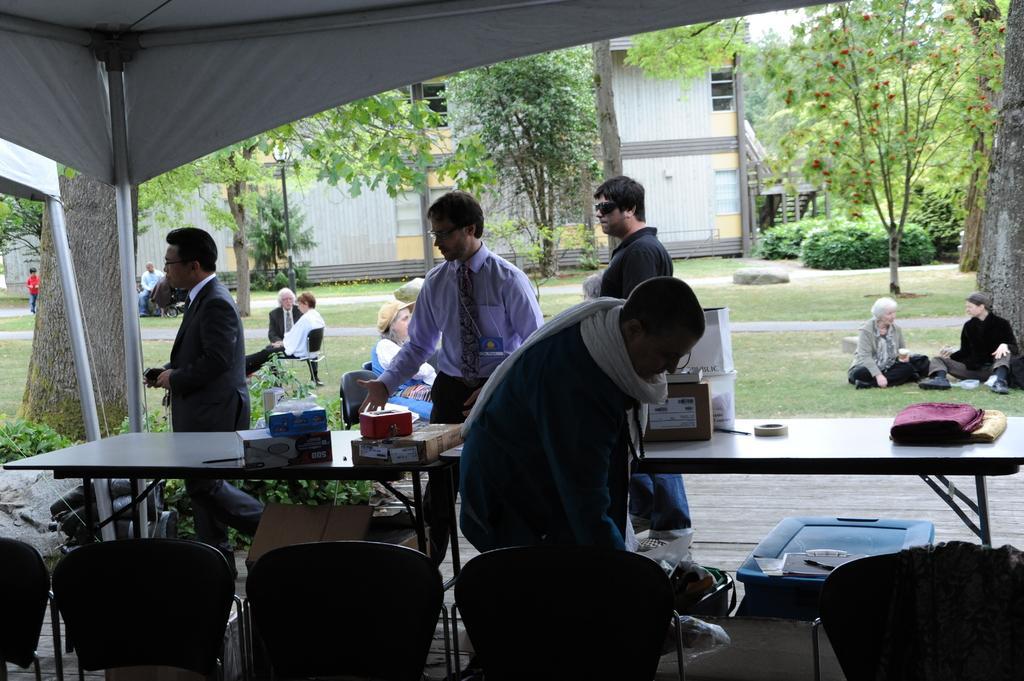Can you describe this image briefly? people are standing around the table. on the table there are boxes and clothes. in the front there are chairs. behind them people are sitting on the grass. at the back there is a building and trees. 